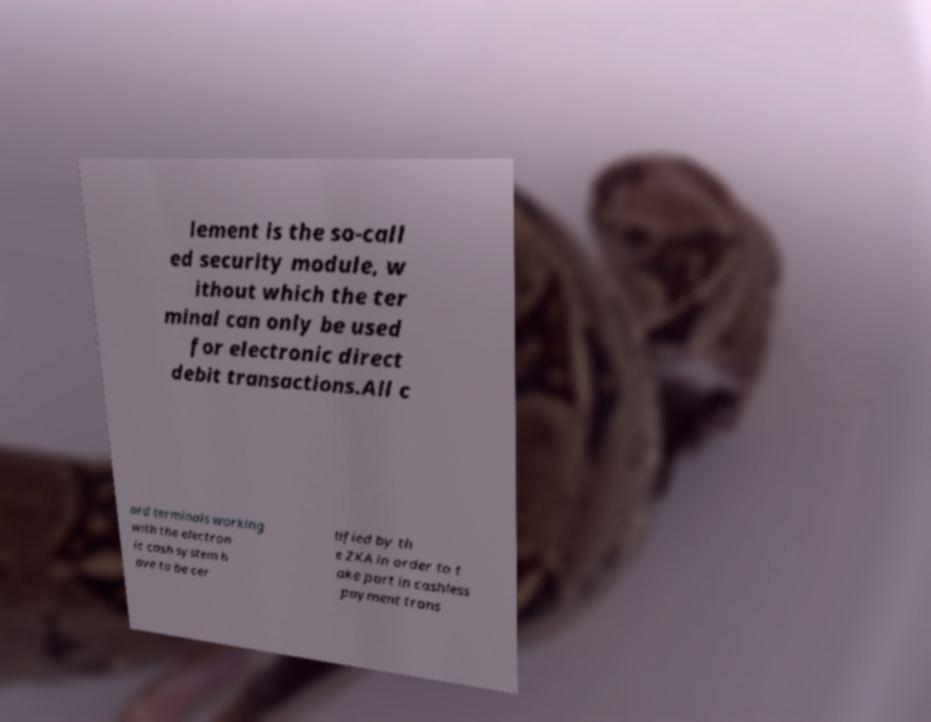Could you extract and type out the text from this image? lement is the so-call ed security module, w ithout which the ter minal can only be used for electronic direct debit transactions.All c ard terminals working with the electron ic cash system h ave to be cer tified by th e ZKA in order to t ake part in cashless payment trans 